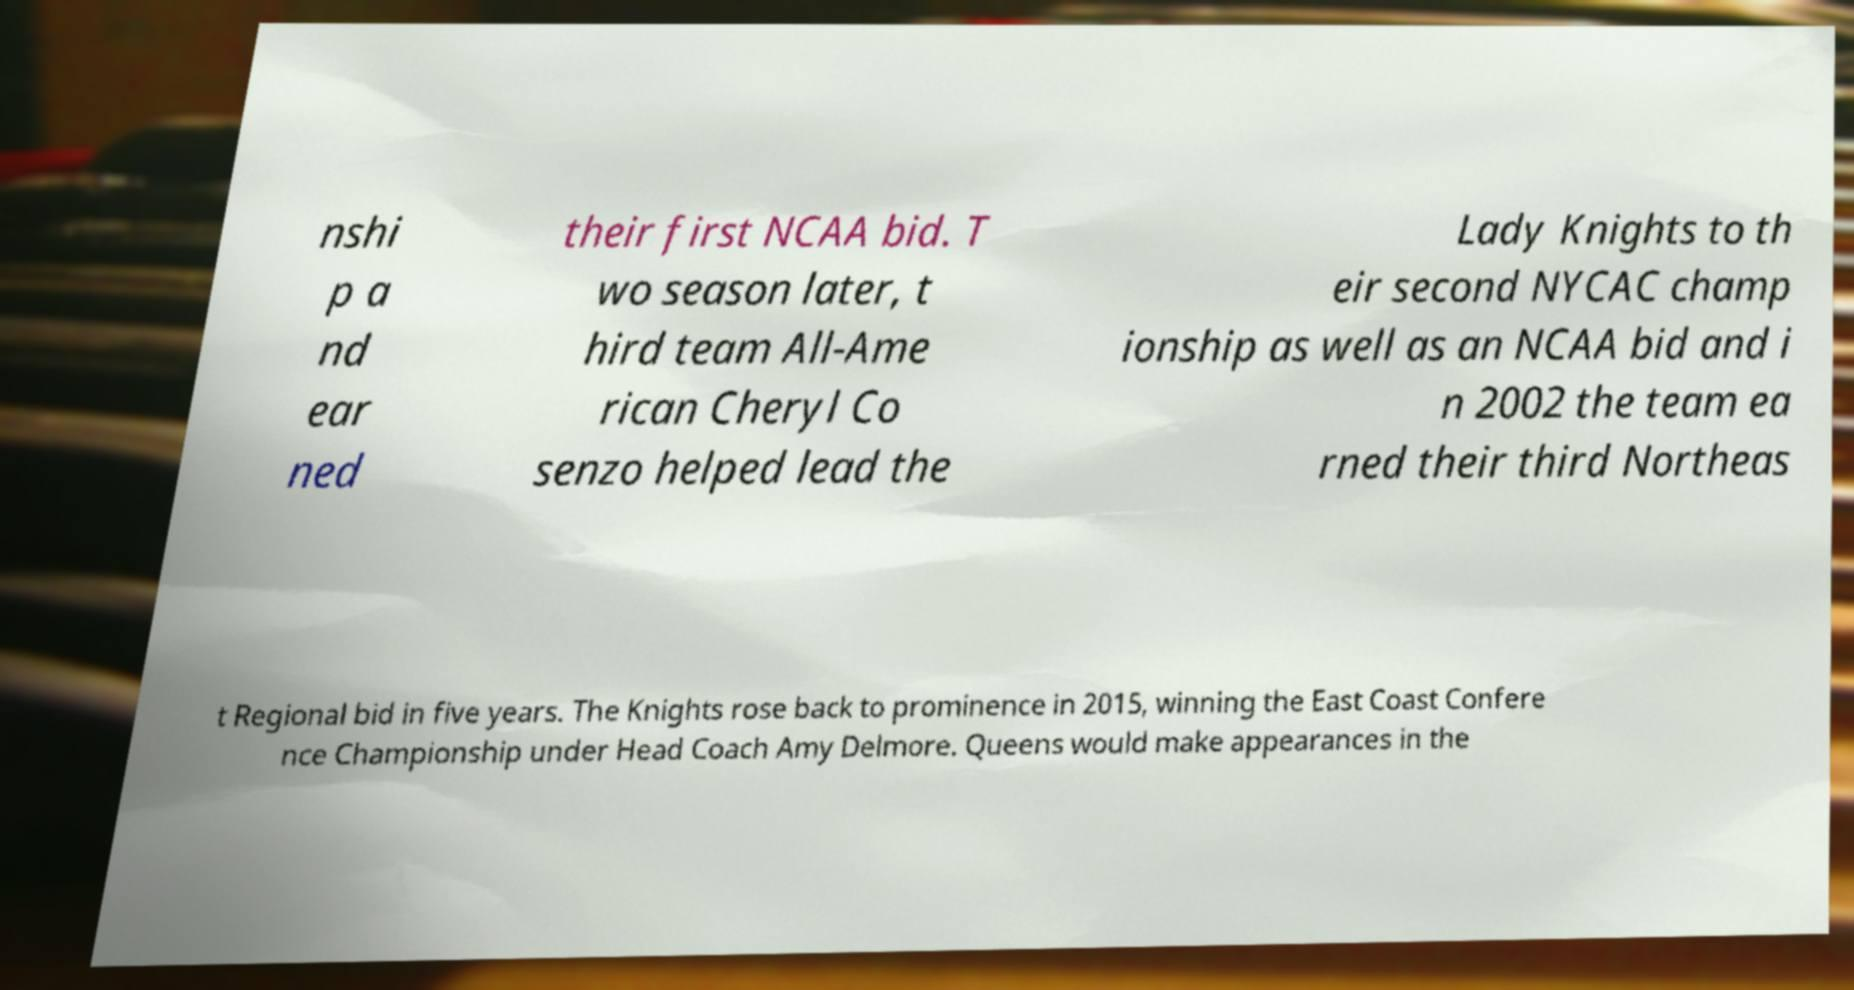Could you extract and type out the text from this image? nshi p a nd ear ned their first NCAA bid. T wo season later, t hird team All-Ame rican Cheryl Co senzo helped lead the Lady Knights to th eir second NYCAC champ ionship as well as an NCAA bid and i n 2002 the team ea rned their third Northeas t Regional bid in five years. The Knights rose back to prominence in 2015, winning the East Coast Confere nce Championship under Head Coach Amy Delmore. Queens would make appearances in the 